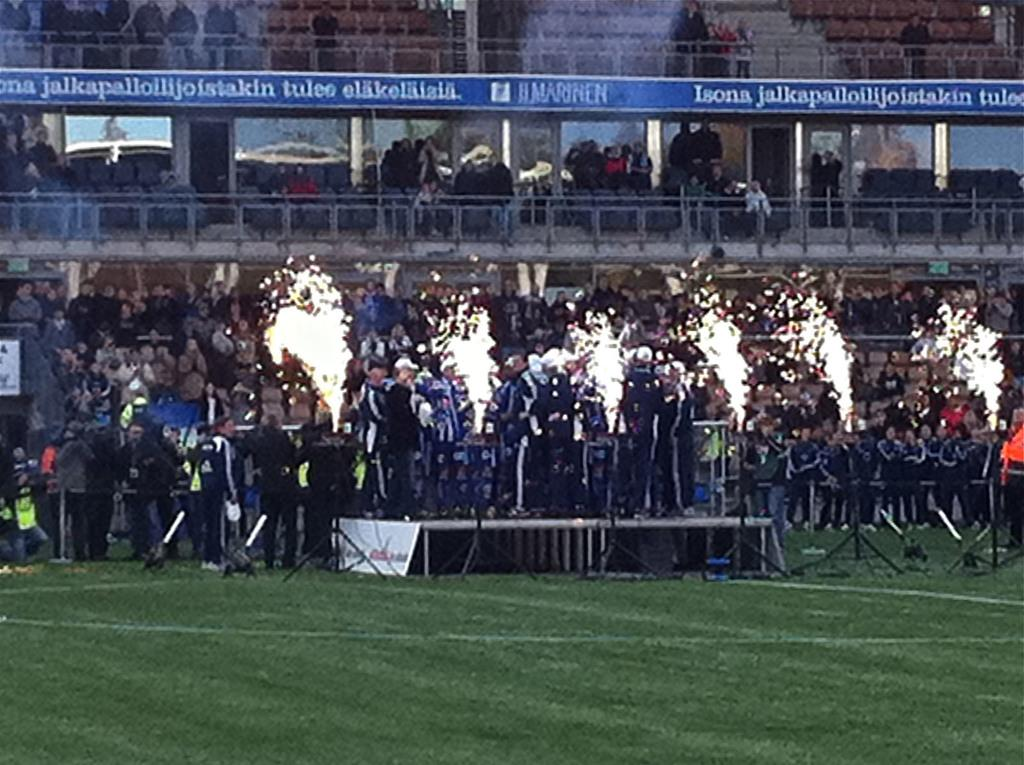Who or what is present in the image? There are people in the image. What type of food can be seen in the image? There are crackers in the image. What structure is featured in the image? There is a stage in the image. What can be seen in the distance in the image? There is a building in the background of the image. What is visible at the bottom of the image? The ground is visible at the bottom of the image. What type of animal is performing on the stage in the image? There is no animal performing on the stage in the image; it is not mentioned in the provided facts. 